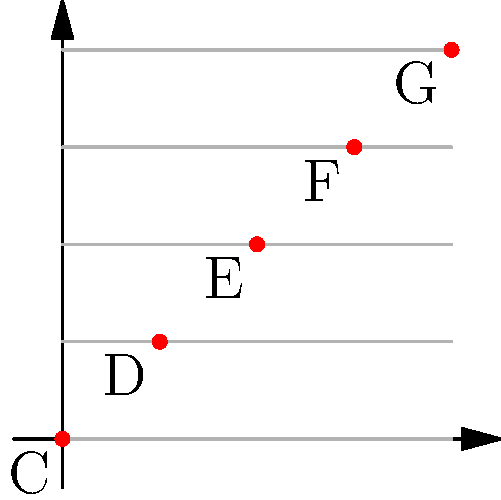Consider the musical staff represented by the graph, where each line and space corresponds to a note (C, D, E, F, G). What is the order of the symmetry group for this arrangement of notes, assuming rotational and reflectional symmetries? Let's approach this step-by-step:

1) First, we need to identify the symmetries present in this arrangement:

   a) Rotational symmetry: The pattern repeats every 360°, so there's only one rotational symmetry (identity).
   
   b) Reflectional symmetry: There's a diagonal line of symmetry from (0,0) to (4,4).

2) To find the order of the symmetry group, we count the number of distinct symmetries:

   - Identity (rotation by 360°): 1
   - Reflection across the diagonal: 1

3) The total number of symmetries is 1 + 1 = 2.

4) In group theory, the order of a group is the number of elements in the group.

5) Therefore, the order of the symmetry group for this arrangement is 2.

This symmetry group is isomorphic to $C_2$, the cyclic group of order 2, which is also isomorphic to the symmetry group of a rectangle.
Answer: 2 